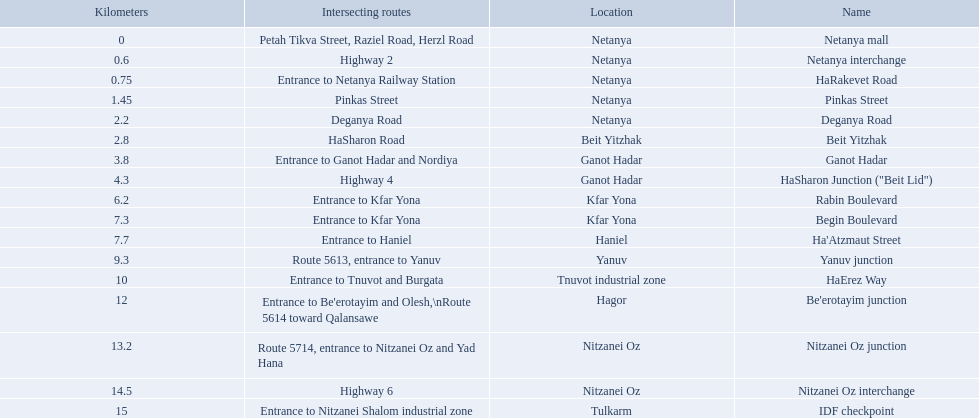Could you parse the entire table as a dict? {'header': ['Kilometers', 'Intersecting routes', 'Location', 'Name'], 'rows': [['0', 'Petah Tikva Street, Raziel Road, Herzl Road', 'Netanya', 'Netanya mall'], ['0.6', 'Highway 2', 'Netanya', 'Netanya interchange'], ['0.75', 'Entrance to Netanya Railway Station', 'Netanya', 'HaRakevet Road'], ['1.45', 'Pinkas Street', 'Netanya', 'Pinkas Street'], ['2.2', 'Deganya Road', 'Netanya', 'Deganya Road'], ['2.8', 'HaSharon Road', 'Beit Yitzhak', 'Beit Yitzhak'], ['3.8', 'Entrance to Ganot Hadar and Nordiya', 'Ganot Hadar', 'Ganot Hadar'], ['4.3', 'Highway 4', 'Ganot Hadar', 'HaSharon Junction ("Beit Lid")'], ['6.2', 'Entrance to Kfar Yona', 'Kfar Yona', 'Rabin Boulevard'], ['7.3', 'Entrance to Kfar Yona', 'Kfar Yona', 'Begin Boulevard'], ['7.7', 'Entrance to Haniel', 'Haniel', "Ha'Atzmaut Street"], ['9.3', 'Route 5613, entrance to Yanuv', 'Yanuv', 'Yanuv junction'], ['10', 'Entrance to Tnuvot and Burgata', 'Tnuvot industrial zone', 'HaErez Way'], ['12', "Entrance to Be'erotayim and Olesh,\\nRoute 5614 toward Qalansawe", 'Hagor', "Be'erotayim junction"], ['13.2', 'Route 5714, entrance to Nitzanei Oz and Yad Hana', 'Nitzanei Oz', 'Nitzanei Oz junction'], ['14.5', 'Highway 6', 'Nitzanei Oz', 'Nitzanei Oz interchange'], ['15', 'Entrance to Nitzanei Shalom industrial zone', 'Tulkarm', 'IDF checkpoint']]} What is the intersecting route of rabin boulevard? Entrance to Kfar Yona. Which portion has this intersecting route? Begin Boulevard. 